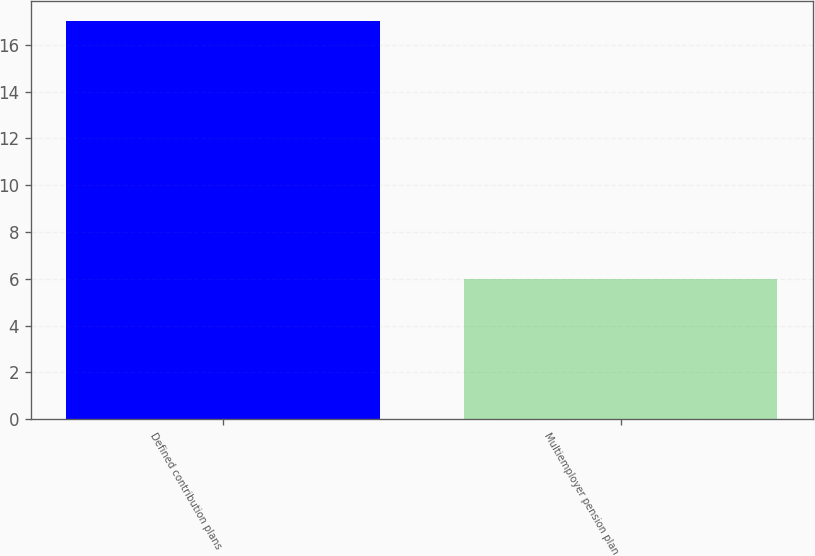<chart> <loc_0><loc_0><loc_500><loc_500><bar_chart><fcel>Defined contribution plans<fcel>Multiemployer pension plan<nl><fcel>17<fcel>6<nl></chart> 